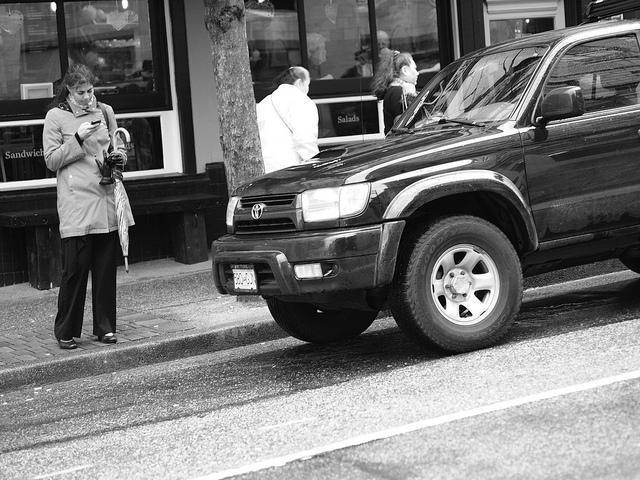How many people can be seen?
Give a very brief answer. 3. 